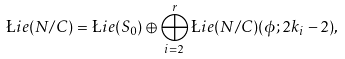Convert formula to latex. <formula><loc_0><loc_0><loc_500><loc_500>\L i e ( N / C ) = \L i e ( S _ { 0 } ) \oplus \bigoplus _ { i = 2 } ^ { r } \L i e ( N / C ) ( \phi ; 2 k _ { i } - 2 ) ,</formula> 